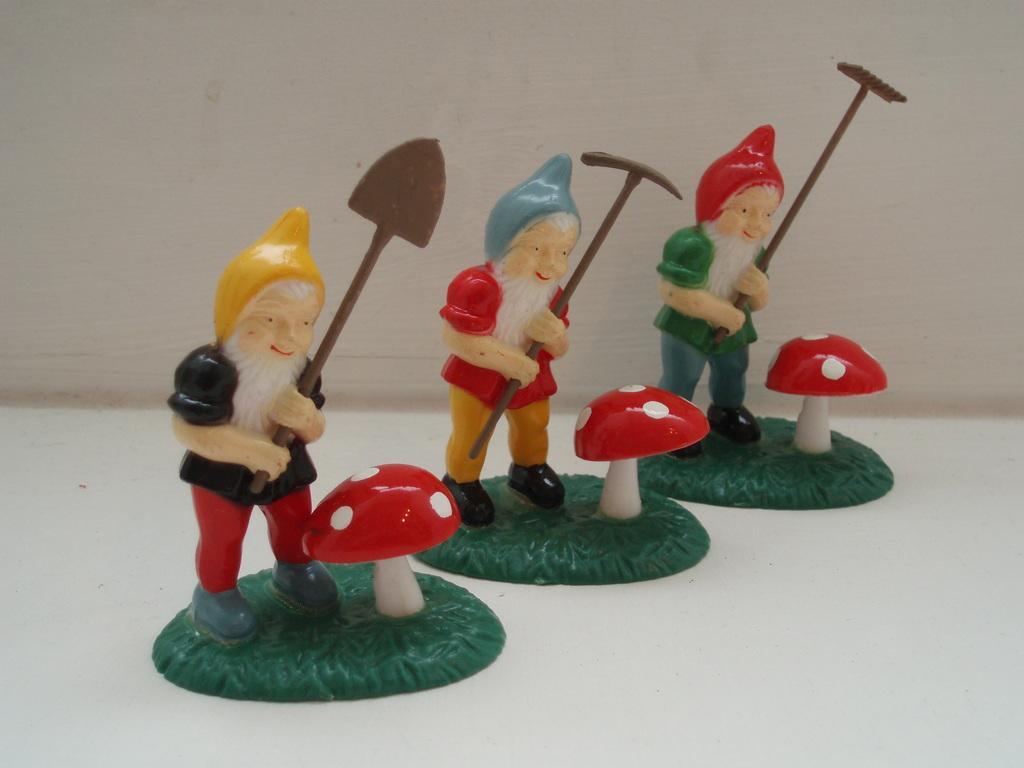Can you describe this image briefly? In this picture we can see toys of persons holding tools with their hands, here we can see mushrooms and these all are on a floor and we can see a wall in the background. 